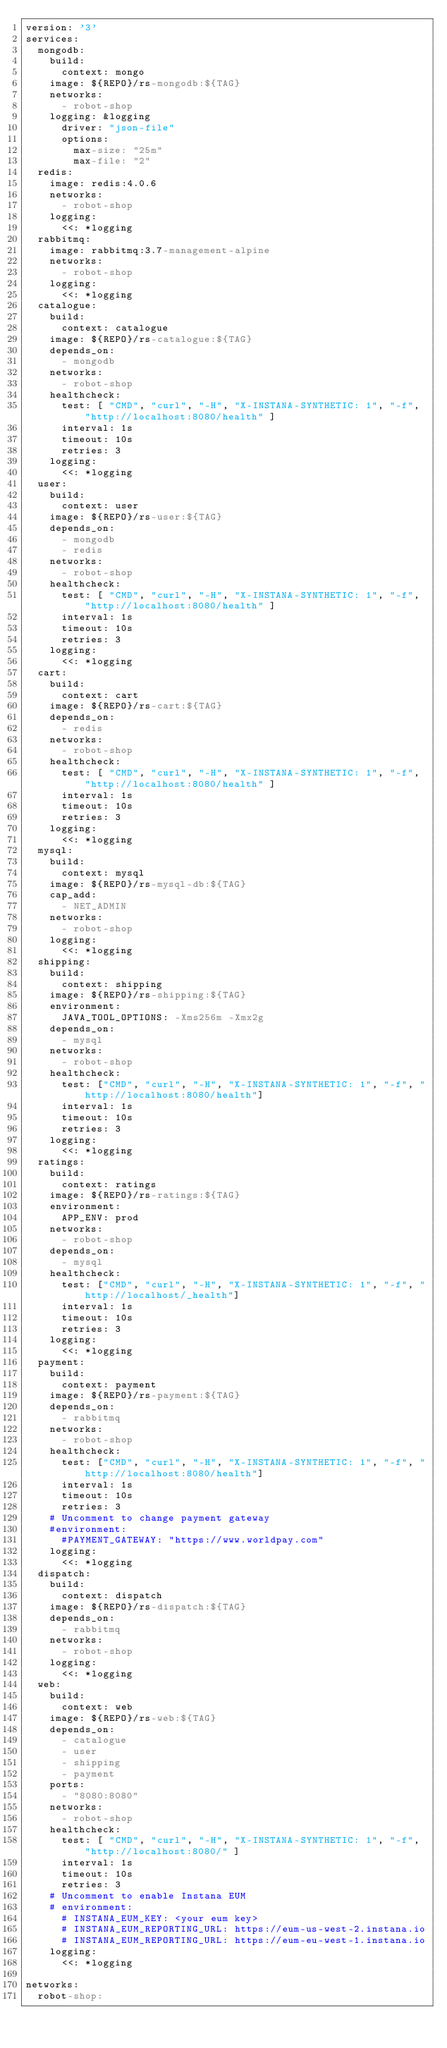<code> <loc_0><loc_0><loc_500><loc_500><_YAML_>version: '3'
services:
  mongodb:
    build:
      context: mongo
    image: ${REPO}/rs-mongodb:${TAG}
    networks:
      - robot-shop
    logging: &logging
      driver: "json-file"
      options:
        max-size: "25m"
        max-file: "2"
  redis:
    image: redis:4.0.6
    networks:
      - robot-shop
    logging:
      <<: *logging
  rabbitmq:
    image: rabbitmq:3.7-management-alpine
    networks:
      - robot-shop
    logging:
      <<: *logging
  catalogue:
    build:
      context: catalogue
    image: ${REPO}/rs-catalogue:${TAG}
    depends_on:
      - mongodb
    networks:
      - robot-shop
    healthcheck:
      test: [ "CMD", "curl", "-H", "X-INSTANA-SYNTHETIC: 1", "-f", "http://localhost:8080/health" ]
      interval: 1s
      timeout: 10s
      retries: 3
    logging:
      <<: *logging
  user:
    build:
      context: user
    image: ${REPO}/rs-user:${TAG}
    depends_on:
      - mongodb
      - redis
    networks:
      - robot-shop
    healthcheck:
      test: [ "CMD", "curl", "-H", "X-INSTANA-SYNTHETIC: 1", "-f", "http://localhost:8080/health" ]
      interval: 1s
      timeout: 10s
      retries: 3
    logging:
      <<: *logging
  cart:
    build:
      context: cart
    image: ${REPO}/rs-cart:${TAG}
    depends_on:
      - redis
    networks:
      - robot-shop
    healthcheck:
      test: [ "CMD", "curl", "-H", "X-INSTANA-SYNTHETIC: 1", "-f", "http://localhost:8080/health" ]
      interval: 1s
      timeout: 10s
      retries: 3
    logging:
      <<: *logging
  mysql:
    build:
      context: mysql
    image: ${REPO}/rs-mysql-db:${TAG}
    cap_add:
      - NET_ADMIN
    networks:
      - robot-shop
    logging:
      <<: *logging
  shipping:
    build:
      context: shipping
    image: ${REPO}/rs-shipping:${TAG}
    environment:
      JAVA_TOOL_OPTIONS: -Xms256m -Xmx2g
    depends_on:
      - mysql
    networks:
      - robot-shop
    healthcheck:
      test: ["CMD", "curl", "-H", "X-INSTANA-SYNTHETIC: 1", "-f", "http://localhost:8080/health"]
      interval: 1s
      timeout: 10s
      retries: 3
    logging:
      <<: *logging
  ratings:
    build:
      context: ratings
    image: ${REPO}/rs-ratings:${TAG}
    environment:
      APP_ENV: prod
    networks:
      - robot-shop
    depends_on:
      - mysql
    healthcheck:
      test: ["CMD", "curl", "-H", "X-INSTANA-SYNTHETIC: 1", "-f", "http://localhost/_health"]
      interval: 1s
      timeout: 10s
      retries: 3
    logging:
      <<: *logging
  payment:
    build:
      context: payment
    image: ${REPO}/rs-payment:${TAG}
    depends_on:
      - rabbitmq
    networks:
      - robot-shop
    healthcheck:
      test: ["CMD", "curl", "-H", "X-INSTANA-SYNTHETIC: 1", "-f", "http://localhost:8080/health"]
      interval: 1s
      timeout: 10s
      retries: 3
    # Uncomment to change payment gateway
    #environment:
      #PAYMENT_GATEWAY: "https://www.worldpay.com"
    logging:
      <<: *logging
  dispatch:
    build:
      context: dispatch
    image: ${REPO}/rs-dispatch:${TAG}
    depends_on:
      - rabbitmq
    networks:
      - robot-shop
    logging:
      <<: *logging
  web:
    build:
      context: web
    image: ${REPO}/rs-web:${TAG}
    depends_on:
      - catalogue
      - user
      - shipping
      - payment
    ports:
      - "8080:8080"
    networks:
      - robot-shop
    healthcheck:
      test: [ "CMD", "curl", "-H", "X-INSTANA-SYNTHETIC: 1", "-f", "http://localhost:8080/" ]
      interval: 1s
      timeout: 10s
      retries: 3
    # Uncomment to enable Instana EUM
    # environment:
      # INSTANA_EUM_KEY: <your eum key>
      # INSTANA_EUM_REPORTING_URL: https://eum-us-west-2.instana.io
      # INSTANA_EUM_REPORTING_URL: https://eum-eu-west-1.instana.io
    logging:
      <<: *logging

networks:
  robot-shop:

</code> 